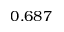<formula> <loc_0><loc_0><loc_500><loc_500>0 . 6 8 7</formula> 